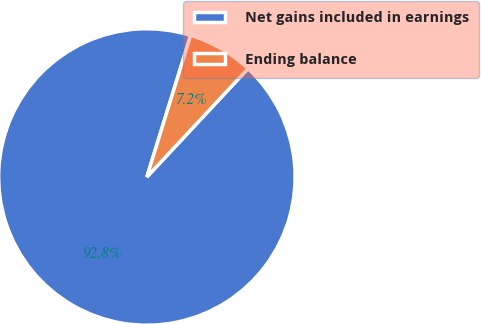<chart> <loc_0><loc_0><loc_500><loc_500><pie_chart><fcel>Net gains included in earnings<fcel>Ending balance<nl><fcel>92.82%<fcel>7.18%<nl></chart> 